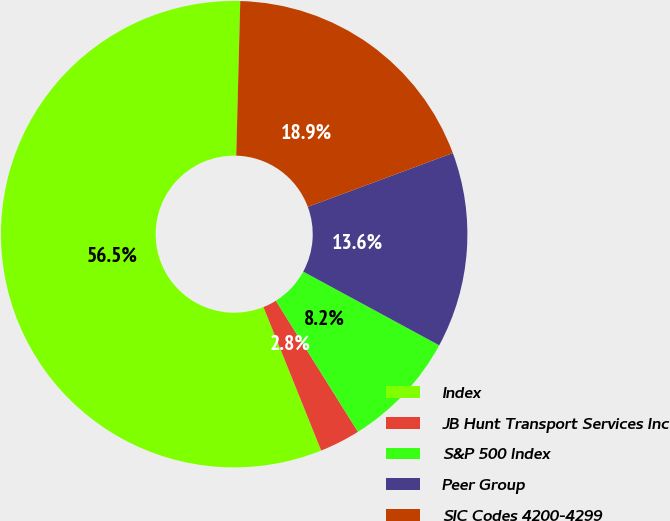<chart> <loc_0><loc_0><loc_500><loc_500><pie_chart><fcel>Index<fcel>JB Hunt Transport Services Inc<fcel>S&P 500 Index<fcel>Peer Group<fcel>SIC Codes 4200-4299<nl><fcel>56.5%<fcel>2.82%<fcel>8.19%<fcel>13.56%<fcel>18.93%<nl></chart> 